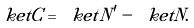Convert formula to latex. <formula><loc_0><loc_0><loc_500><loc_500>\ k e t { C } = \ k e t { N ^ { \prime } } - \ k e t { N } .</formula> 